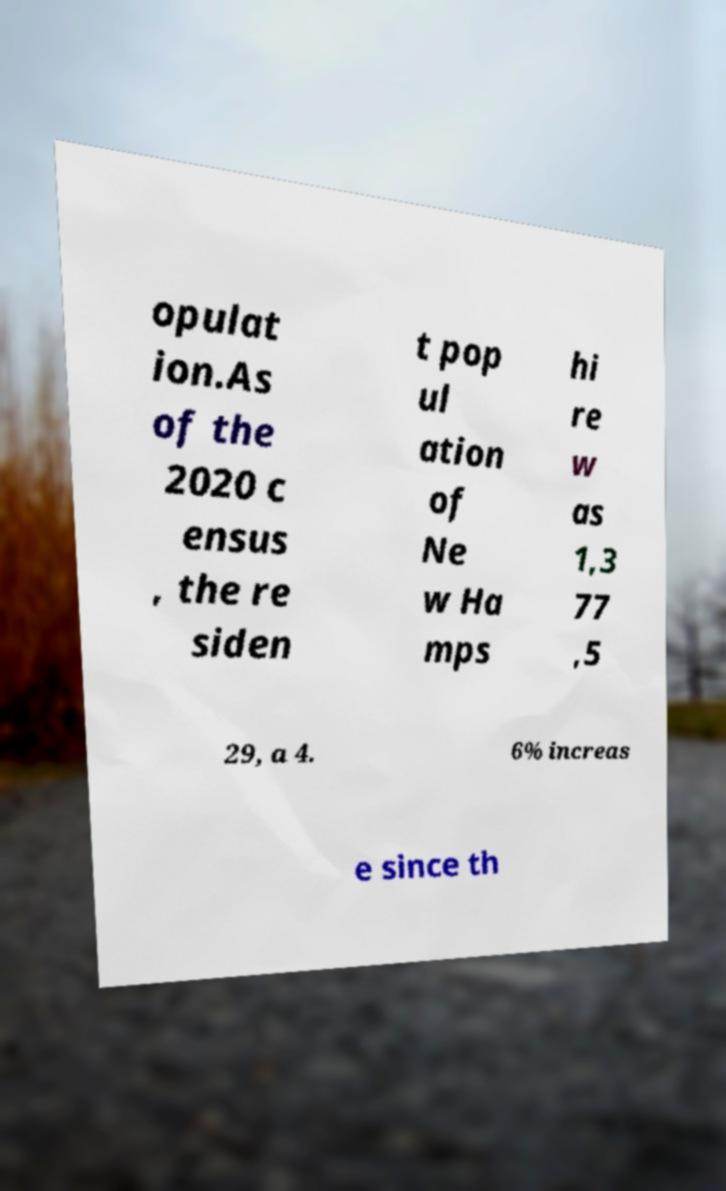I need the written content from this picture converted into text. Can you do that? opulat ion.As of the 2020 c ensus , the re siden t pop ul ation of Ne w Ha mps hi re w as 1,3 77 ,5 29, a 4. 6% increas e since th 